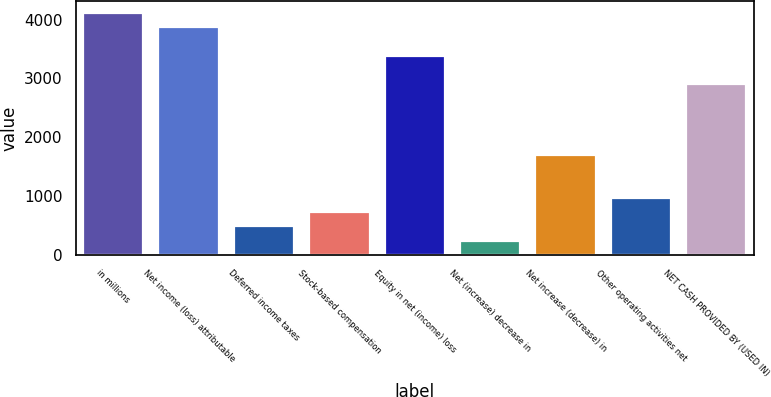Convert chart. <chart><loc_0><loc_0><loc_500><loc_500><bar_chart><fcel>in millions<fcel>Net income (loss) attributable<fcel>Deferred income taxes<fcel>Stock-based compensation<fcel>Equity in net (income) loss<fcel>Net (increase) decrease in<fcel>Net increase (decrease) in<fcel>Other operating activities net<fcel>NET CASH PROVIDED BY (USED IN)<nl><fcel>4109.2<fcel>3867.6<fcel>485.2<fcel>726.8<fcel>3384.4<fcel>243.6<fcel>1693.2<fcel>968.4<fcel>2901.2<nl></chart> 